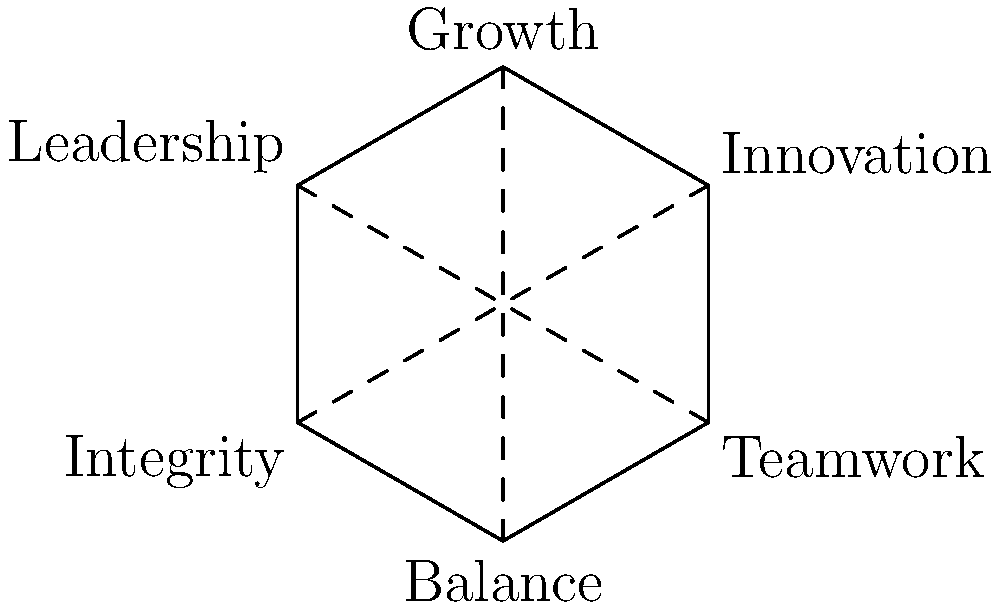In the hexagon above, workplace values are labeled at each vertex. How many lines of symmetry does this hexagon have, and what does this imply about the balance of these values in a harmonious workplace? To determine the number of lines of symmetry in a regular hexagon and understand its implications for workplace values, let's follow these steps:

1. Identify the lines of symmetry:
   a) Vertex to vertex: There are 3 lines connecting opposite vertices (shown as dashed lines in the diagram).
   b) Midpoint to midpoint: There are 3 lines connecting the midpoints of opposite sides (not shown in the diagram).

2. Count the total number of lines of symmetry:
   Total lines of symmetry = Vertex-to-vertex lines + Midpoint-to-midpoint lines
   Total lines of symmetry = 3 + 3 = 6

3. Interpret the symmetry in the context of workplace values:
   a) Each line of symmetry divides the hexagon into two equal halves, suggesting balance and equality among the values.
   b) The 6 lines of symmetry indicate that the workplace values are highly interconnected and harmonious.
   c) Rotational symmetry (120° rotations) implies that each value is equally important and contributes to the overall balance.

4. Implications for a harmonious workplace:
   a) Balance: The symmetry suggests that all six values should be given equal importance for a well-rounded workplace.
   b) Interconnectedness: The multiple lines of symmetry show that these values are interrelated and support each other.
   c) Flexibility: The rotational symmetry implies that the workplace can adapt while maintaining its core values.
   d) Holistic approach: The perfect symmetry encourages considering all aspects of the workplace for true harmony.

In conclusion, the 6 lines of symmetry in the hexagon emphasize the importance of balance, interconnectedness, and equal consideration of all core values for creating a harmonious and positive workplace environment.
Answer: 6 lines of symmetry; implies balance, interconnectedness, and equal importance of all workplace values. 